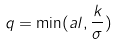<formula> <loc_0><loc_0><loc_500><loc_500>q = \min ( a l , \frac { k } { \sigma } )</formula> 